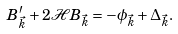Convert formula to latex. <formula><loc_0><loc_0><loc_500><loc_500>B _ { \vec { k } } ^ { \prime } + 2 { \mathcal { H } } B _ { \vec { k } } = - \phi _ { \vec { k } } + \Delta _ { \vec { k } } .</formula> 